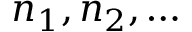<formula> <loc_0><loc_0><loc_500><loc_500>n _ { 1 } , n _ { 2 } , \dots</formula> 